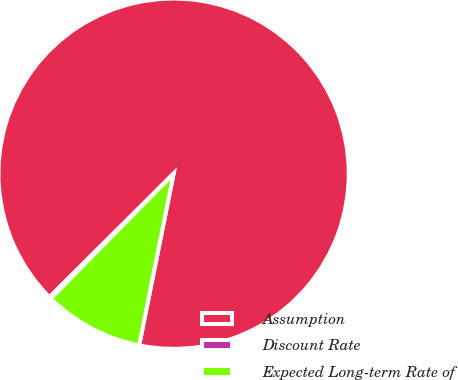Convert chart to OTSL. <chart><loc_0><loc_0><loc_500><loc_500><pie_chart><fcel>Assumption<fcel>Discount Rate<fcel>Expected Long-term Rate of<nl><fcel>90.61%<fcel>0.17%<fcel>9.22%<nl></chart> 